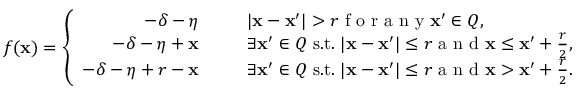<formula> <loc_0><loc_0><loc_500><loc_500>f ( \mathbf x ) = \left \{ \begin{array} { r l } { - \delta - \eta } & { | \mathbf x - \mathbf x ^ { \prime } | > r f o r a n y \mathbf x ^ { \prime } \in Q , } \\ { - \delta - \eta + \mathbf x } & { \exists \mathbf x ^ { \prime } \in Q s . t . | \mathbf x - \mathbf x ^ { \prime } | \leq r a n d \mathbf x \leq \mathbf x ^ { \prime } + \frac { r } { 2 } , } \\ { - \delta - \eta + r - \mathbf x } & { \exists \mathbf x ^ { \prime } \in Q s . t . | \mathbf x - \mathbf x ^ { \prime } | \leq r a n d \mathbf x > \mathbf x ^ { \prime } + \frac { r } { 2 } . } \end{array}</formula> 